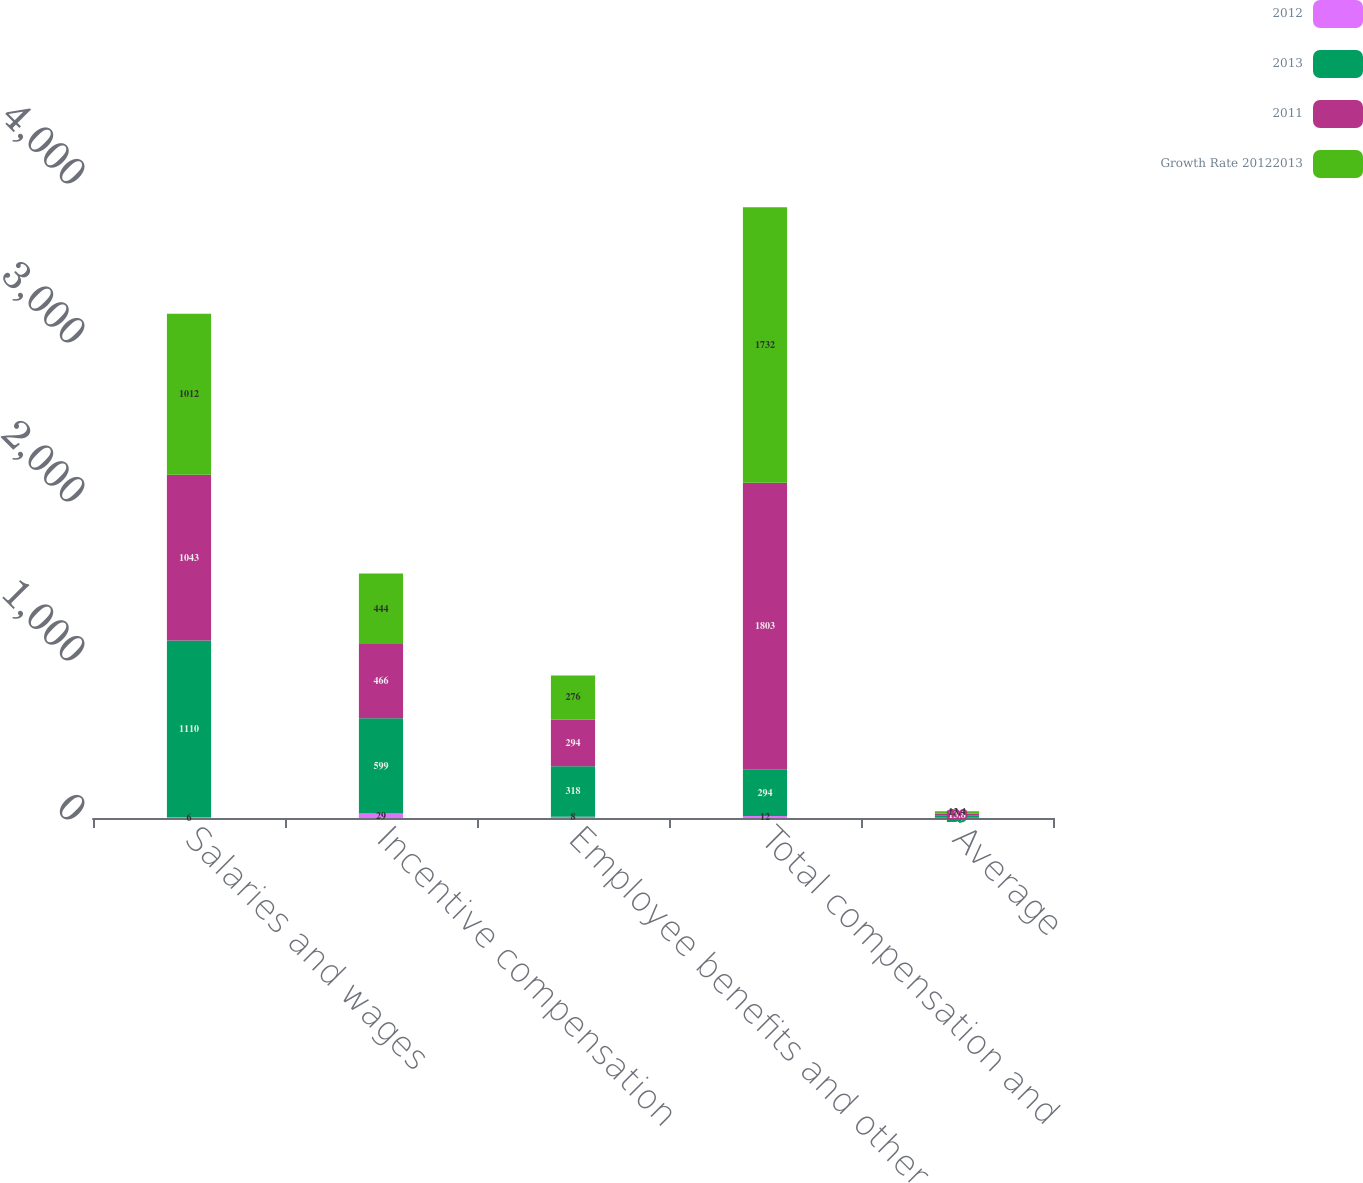Convert chart. <chart><loc_0><loc_0><loc_500><loc_500><stacked_bar_chart><ecel><fcel>Salaries and wages<fcel>Incentive compensation<fcel>Employee benefits and other<fcel>Total compensation and<fcel>Average<nl><fcel>2012<fcel>6<fcel>29<fcel>8<fcel>12<fcel>1<nl><fcel>2013<fcel>1110<fcel>599<fcel>318<fcel>294<fcel>13.9<nl><fcel>2011<fcel>1043<fcel>466<fcel>294<fcel>1803<fcel>13.8<nl><fcel>Growth Rate 20122013<fcel>1012<fcel>444<fcel>276<fcel>1732<fcel>13.4<nl></chart> 